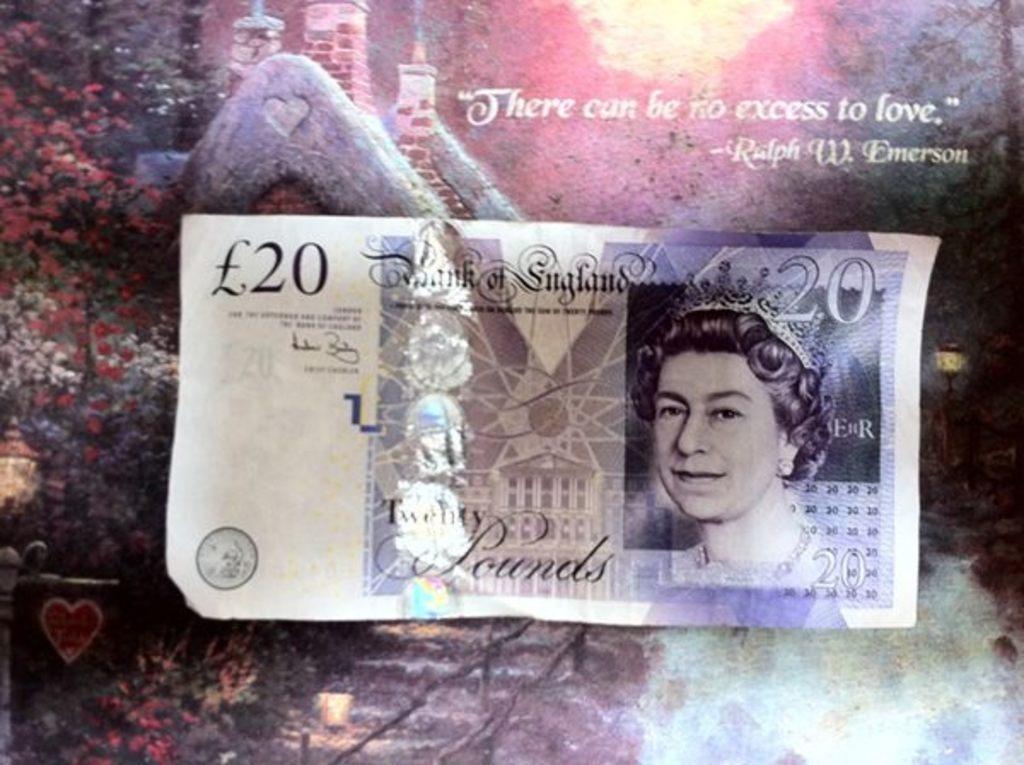Could you give a brief overview of what you see in this image? In this image I can see pounds note, trees, buildings and multi-color in the background. This image looks like an edited photo. 